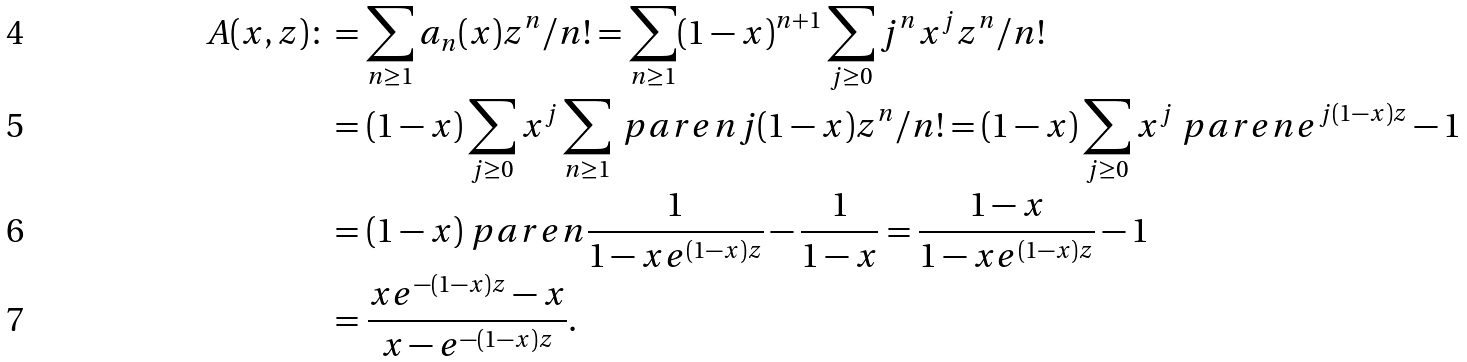<formula> <loc_0><loc_0><loc_500><loc_500>A ( x , z ) \colon & = \sum _ { n \geq 1 } a _ { n } ( x ) z ^ { n } / n ! = \sum _ { n \geq 1 } ( 1 - x ) ^ { n + 1 } \sum _ { j \geq 0 } j ^ { n } x ^ { j } z ^ { n } / n ! \\ & = ( 1 - x ) \sum _ { j \geq 0 } x ^ { j } \sum _ { n \geq 1 } \ p a r e n { j ( 1 - x ) z } ^ { n } / n ! = ( 1 - x ) \sum _ { j \geq 0 } x ^ { j } \ p a r e n { e ^ { j ( 1 - x ) z } - 1 } \\ & = ( 1 - x ) \ p a r e n { \frac { 1 } { 1 - x e ^ { ( 1 - x ) z } } - \frac { 1 } { 1 - x } } = \frac { 1 - x } { 1 - x e ^ { ( 1 - x ) z } } - 1 \\ & = \frac { x e ^ { - ( 1 - x ) z } - x } { x - e ^ { - ( 1 - x ) z } } .</formula> 